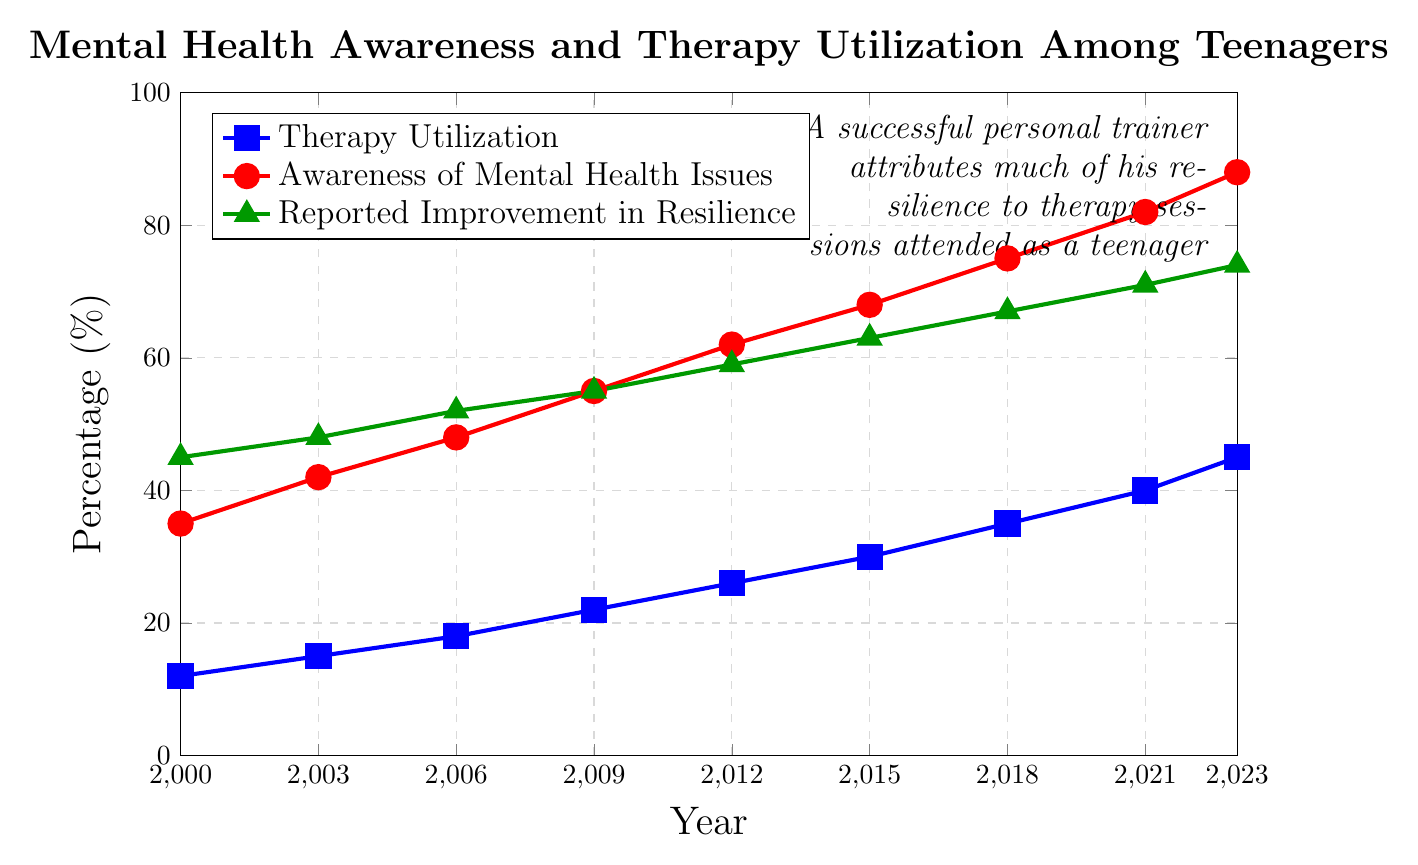What trends can be observed in therapy utilization and awareness of mental health issues from 2000 to 2023? Observing the line chart, both therapy utilization and awareness of mental health issues show an upward trend from 2000 to 2023. Therapy utilization starts at 12% in 2000 and rises to 45% in 2023. Awareness of mental health issues starts at 35% in 2000 and rises to 88% in 2023.
Answer: Both metrics increase steadily In which year did reported improvement in resilience exceed 60%? From the chart, reported improvement in resilience exceeded 60% in 2015, reaching 63%.
Answer: 2015 Which year saw the highest increase in awareness of mental health issues as compared to the previous recorded year? To determine this, we need to calculate the difference in awareness percentage for each year: 
42-35 (2003-2000) = 7%, 
48-42 (2006-2003) = 6%, 
55-48 (2009-2006) = 7%, 
62-55 (2012-2009) = 7%, 
68-62 (2015-2012) = 6%, 
75-68 (2018-2015) = 7%, 
82-75 (2021-2018) = 7%, 
88-82 (2023-2021) = 6%.
The largest increases of 7% occurred in the years 2003, 2009, 2012, 2018, and 2021.
Answer: 2003, 2009, 2012, 2018, and 2021 How did the reported improvement in resilience change from 2000 to 2023? In 2000, the reported improvement in resilience was at 45%. By 2023, it increased to 74%. The change, therefore, is 74% - 45% = 29%.
Answer: It increased by 29% When did the average therapy sessions per year first reach double digits? The chart shows that the average therapy sessions per year reached double digits (10 sessions) in 2012.
Answer: 2012 Is there a correlation between therapy utilization and reported improvement in resilience? Observing the chart, both therapy utilization and reported improvement in resilience show a positive trend over the years. As therapy utilization increases, reported improvement in resilience also increases. This suggests a positive correlation.
Answer: Yes, there appears to be a positive correlation 